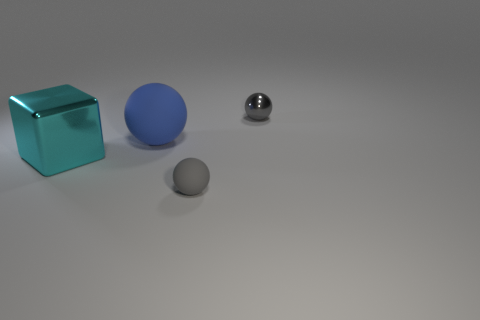Subtract all blue matte balls. How many balls are left? 2 Subtract all green blocks. How many gray spheres are left? 2 Add 1 small gray objects. How many objects exist? 5 Subtract all spheres. How many objects are left? 1 Subtract all small balls. Subtract all blue things. How many objects are left? 1 Add 1 gray things. How many gray things are left? 3 Add 1 tiny brown metal blocks. How many tiny brown metal blocks exist? 1 Subtract 2 gray spheres. How many objects are left? 2 Subtract all green balls. Subtract all gray cylinders. How many balls are left? 3 